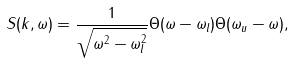<formula> <loc_0><loc_0><loc_500><loc_500>S ( k , \omega ) = \frac { 1 } { \sqrt { \omega ^ { 2 } - \omega _ { l } ^ { 2 } } } \Theta ( \omega - \omega _ { l } ) \Theta ( \omega _ { u } - \omega ) ,</formula> 